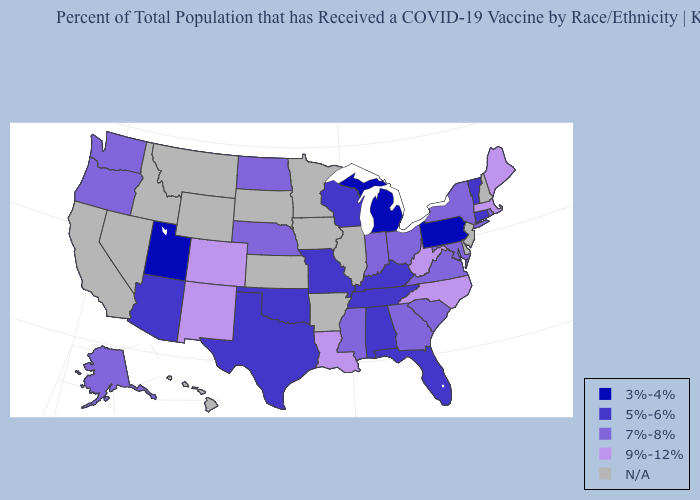What is the value of Texas?
Be succinct. 5%-6%. Among the states that border New Jersey , does New York have the highest value?
Give a very brief answer. Yes. Which states hav the highest value in the South?
Quick response, please. Louisiana, North Carolina, West Virginia. What is the lowest value in states that border California?
Keep it brief. 5%-6%. Does Massachusetts have the highest value in the Northeast?
Give a very brief answer. Yes. What is the lowest value in the Northeast?
Quick response, please. 3%-4%. Does the map have missing data?
Write a very short answer. Yes. What is the value of Maryland?
Write a very short answer. 7%-8%. Name the states that have a value in the range 9%-12%?
Write a very short answer. Colorado, Louisiana, Maine, Massachusetts, New Mexico, North Carolina, West Virginia. Name the states that have a value in the range 3%-4%?
Be succinct. Michigan, Pennsylvania, Utah. Does North Carolina have the highest value in the South?
Write a very short answer. Yes. Which states have the lowest value in the USA?
Answer briefly. Michigan, Pennsylvania, Utah. Among the states that border Florida , does Georgia have the highest value?
Write a very short answer. Yes. What is the lowest value in the USA?
Write a very short answer. 3%-4%. Does Rhode Island have the lowest value in the Northeast?
Answer briefly. No. 